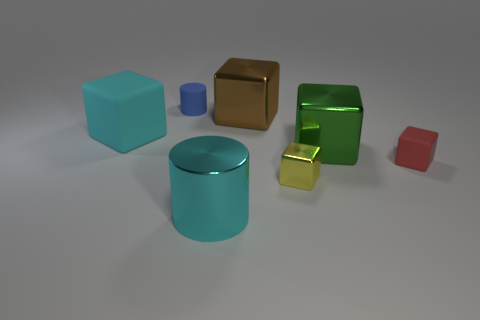Subtract all brown blocks. How many blocks are left? 4 Subtract all green metal blocks. How many blocks are left? 4 Add 2 large green metallic cubes. How many objects exist? 9 Subtract all purple blocks. Subtract all blue spheres. How many blocks are left? 5 Subtract all cylinders. How many objects are left? 5 Subtract all small green balls. Subtract all yellow cubes. How many objects are left? 6 Add 7 tiny red matte cubes. How many tiny red matte cubes are left? 8 Add 7 gray metal cubes. How many gray metal cubes exist? 7 Subtract 1 yellow blocks. How many objects are left? 6 